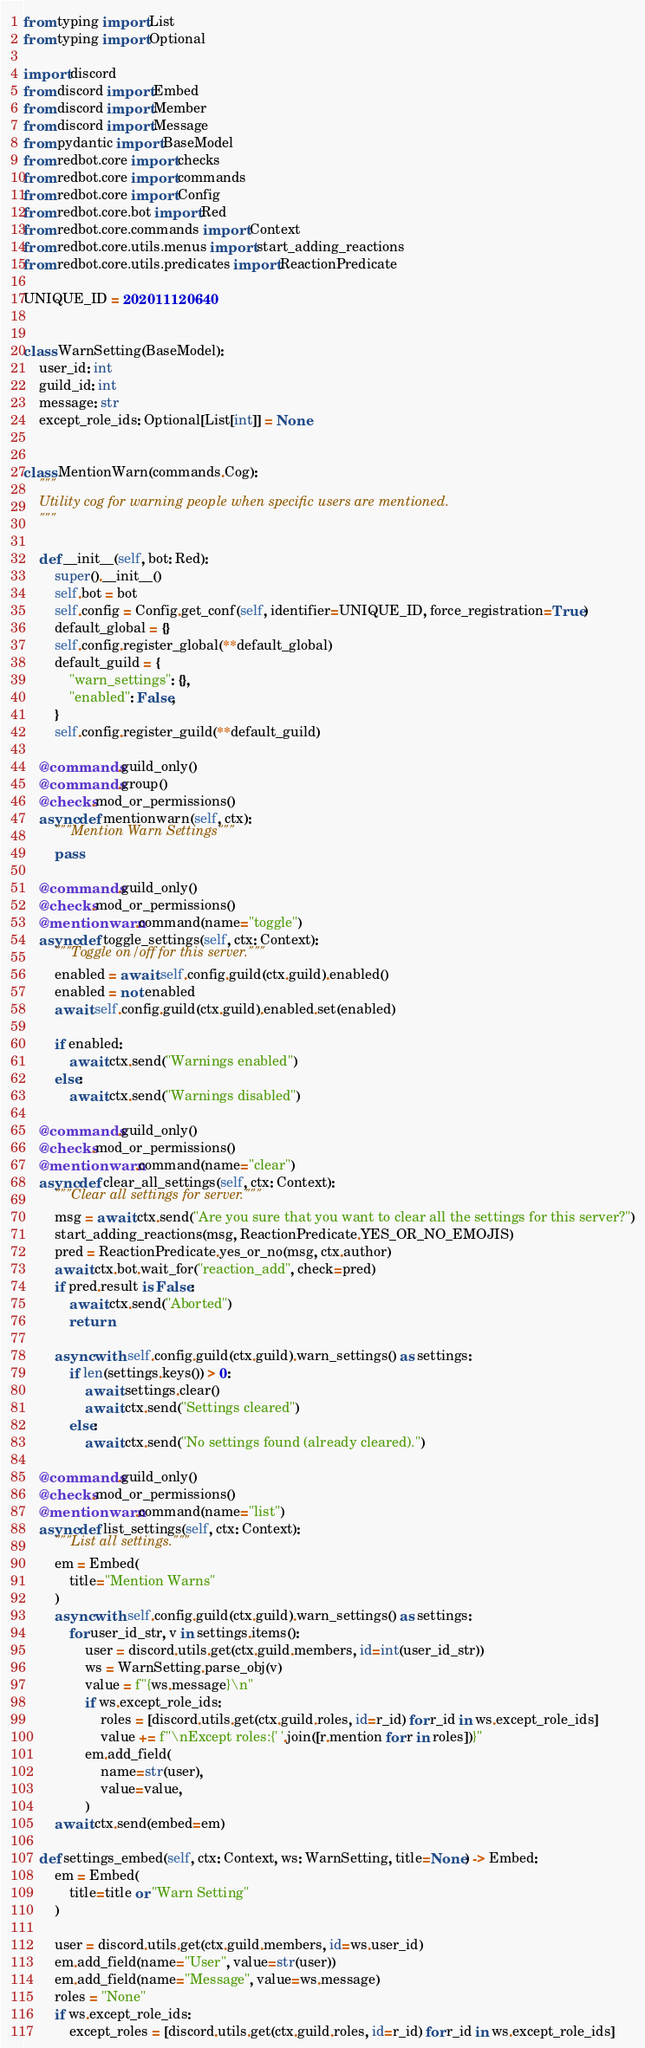<code> <loc_0><loc_0><loc_500><loc_500><_Python_>from typing import List
from typing import Optional

import discord
from discord import Embed
from discord import Member
from discord import Message
from pydantic import BaseModel
from redbot.core import checks
from redbot.core import commands
from redbot.core import Config
from redbot.core.bot import Red
from redbot.core.commands import Context
from redbot.core.utils.menus import start_adding_reactions
from redbot.core.utils.predicates import ReactionPredicate

UNIQUE_ID = 202011120640


class WarnSetting(BaseModel):
    user_id: int
    guild_id: int
    message: str
    except_role_ids: Optional[List[int]] = None


class MentionWarn(commands.Cog):
    """
    Utility cog for warning people when specific users are mentioned.
    """

    def __init__(self, bot: Red):
        super().__init__()
        self.bot = bot
        self.config = Config.get_conf(self, identifier=UNIQUE_ID, force_registration=True)
        default_global = {}
        self.config.register_global(**default_global)
        default_guild = {
            "warn_settings": {},
            "enabled": False,
        }
        self.config.register_guild(**default_guild)

    @commands.guild_only()
    @commands.group()
    @checks.mod_or_permissions()
    async def mentionwarn(self, ctx):
        """Mention Warn Settings"""
        pass

    @commands.guild_only()
    @checks.mod_or_permissions()
    @mentionwarn.command(name="toggle")
    async def toggle_settings(self, ctx: Context):
        """Toggle on/off for this server."""
        enabled = await self.config.guild(ctx.guild).enabled()
        enabled = not enabled
        await self.config.guild(ctx.guild).enabled.set(enabled)

        if enabled:
            await ctx.send("Warnings enabled")
        else:
            await ctx.send("Warnings disabled")

    @commands.guild_only()
    @checks.mod_or_permissions()
    @mentionwarn.command(name="clear")
    async def clear_all_settings(self, ctx: Context):
        """Clear all settings for server."""
        msg = await ctx.send("Are you sure that you want to clear all the settings for this server?")
        start_adding_reactions(msg, ReactionPredicate.YES_OR_NO_EMOJIS)
        pred = ReactionPredicate.yes_or_no(msg, ctx.author)
        await ctx.bot.wait_for("reaction_add", check=pred)
        if pred.result is False:
            await ctx.send("Aborted")
            return

        async with self.config.guild(ctx.guild).warn_settings() as settings:
            if len(settings.keys()) > 0:
                await settings.clear()
                await ctx.send("Settings cleared")
            else:
                await ctx.send("No settings found (already cleared).")

    @commands.guild_only()
    @checks.mod_or_permissions()
    @mentionwarn.command(name="list")
    async def list_settings(self, ctx: Context):
        """List all settings."""
        em = Embed(
            title="Mention Warns"
        )
        async with self.config.guild(ctx.guild).warn_settings() as settings:
            for user_id_str, v in settings.items():
                user = discord.utils.get(ctx.guild.members, id=int(user_id_str))
                ws = WarnSetting.parse_obj(v)
                value = f"{ws.message}\n"
                if ws.except_role_ids:
                    roles = [discord.utils.get(ctx.guild.roles, id=r_id) for r_id in ws.except_role_ids]
                    value += f"\nExcept roles:{' '.join([r.mention for r in roles])}"
                em.add_field(
                    name=str(user),
                    value=value,
                )
        await ctx.send(embed=em)

    def settings_embed(self, ctx: Context, ws: WarnSetting, title=None) -> Embed:
        em = Embed(
            title=title or "Warn Setting"
        )

        user = discord.utils.get(ctx.guild.members, id=ws.user_id)
        em.add_field(name="User", value=str(user))
        em.add_field(name="Message", value=ws.message)
        roles = "None"
        if ws.except_role_ids:
            except_roles = [discord.utils.get(ctx.guild.roles, id=r_id) for r_id in ws.except_role_ids]</code> 